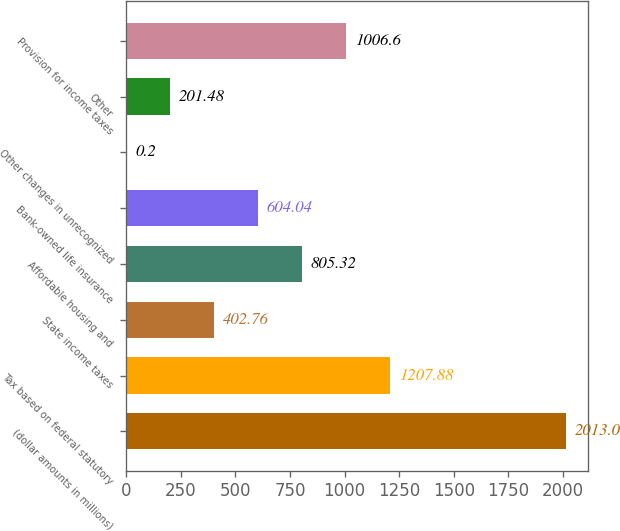<chart> <loc_0><loc_0><loc_500><loc_500><bar_chart><fcel>(dollar amounts in millions)<fcel>Tax based on federal statutory<fcel>State income taxes<fcel>Affordable housing and<fcel>Bank-owned life insurance<fcel>Other changes in unrecognized<fcel>Other<fcel>Provision for income taxes<nl><fcel>2013<fcel>1207.88<fcel>402.76<fcel>805.32<fcel>604.04<fcel>0.2<fcel>201.48<fcel>1006.6<nl></chart> 